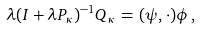Convert formula to latex. <formula><loc_0><loc_0><loc_500><loc_500>\lambda ( I + \lambda P _ { \kappa } ) ^ { - 1 } Q _ { \kappa } \, = \, ( \psi , \cdot ) \phi \, ,</formula> 